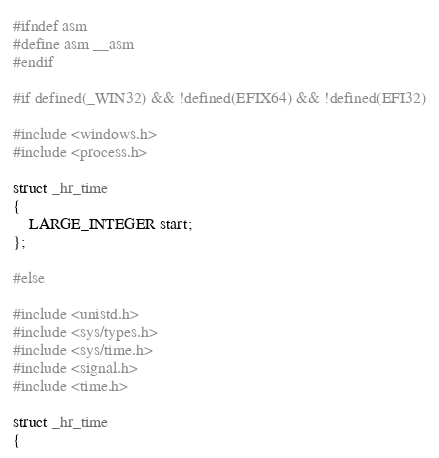<code> <loc_0><loc_0><loc_500><loc_500><_C_>#ifndef asm
#define asm __asm
#endif

#if defined(_WIN32) && !defined(EFIX64) && !defined(EFI32)

#include <windows.h>
#include <process.h>

struct _hr_time
{
    LARGE_INTEGER start;
};

#else

#include <unistd.h>
#include <sys/types.h>
#include <sys/time.h>
#include <signal.h>
#include <time.h>

struct _hr_time
{</code> 